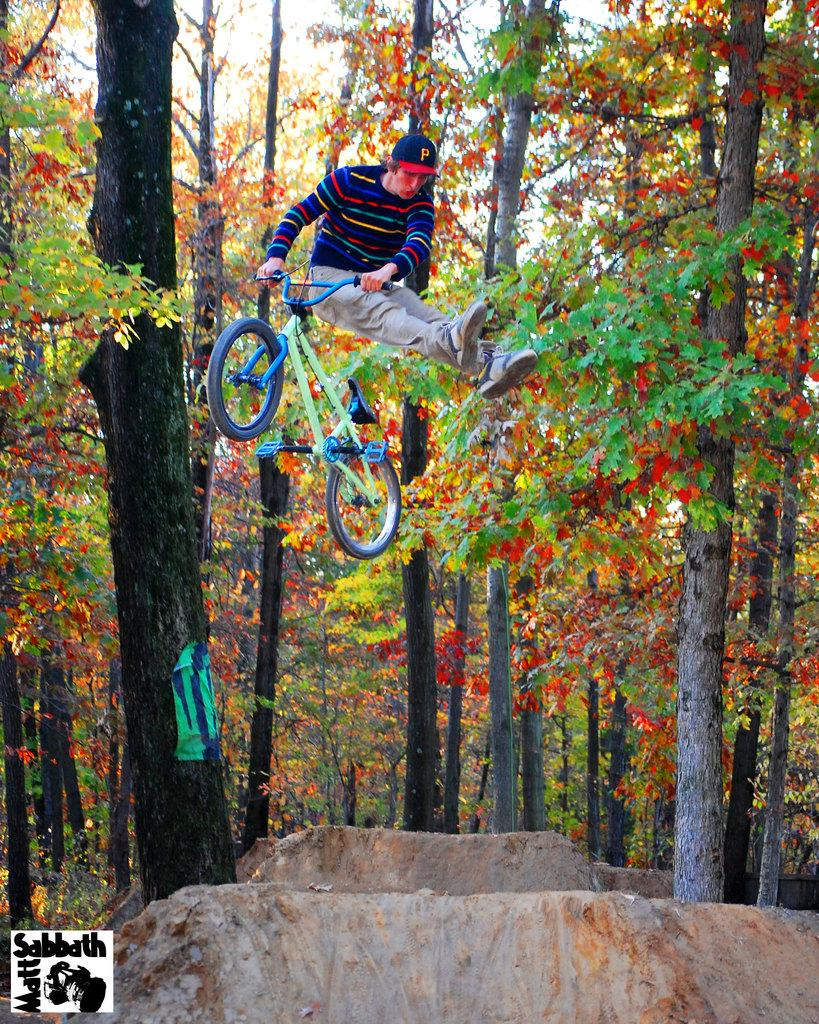What is the main subject of the image? The main subject of the image is a man. What is the man wearing? The man is wearing a t-shirt and a cap. What action is the man performing in the image? The man is jumping. What object is the man holding in the image? The man is holding a bicycle. What can be seen in the background of the image? There are trees, sky, and plants visible in the background of the image. How many dogs are present in the image? There are no dogs present in the image; it features a man jumping while holding a bicycle. What type of stick is the baby holding in the image? There is no baby or stick present in the image. 